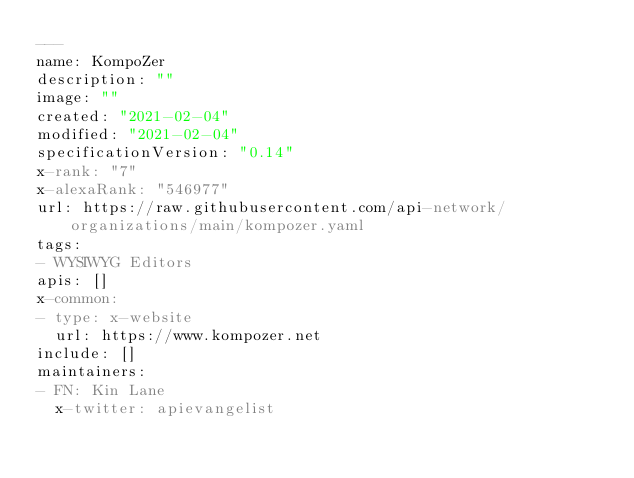<code> <loc_0><loc_0><loc_500><loc_500><_YAML_>---
name: KompoZer
description: ""
image: ""
created: "2021-02-04"
modified: "2021-02-04"
specificationVersion: "0.14"
x-rank: "7"
x-alexaRank: "546977"
url: https://raw.githubusercontent.com/api-network/organizations/main/kompozer.yaml
tags:
- WYSIWYG Editors
apis: []
x-common:
- type: x-website
  url: https://www.kompozer.net
include: []
maintainers:
- FN: Kin Lane
  x-twitter: apievangelist</code> 